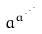<formula> <loc_0><loc_0><loc_500><loc_500>a ^ { a ^ { \cdot ^ { \cdot ^ { \cdot } } } }</formula> 